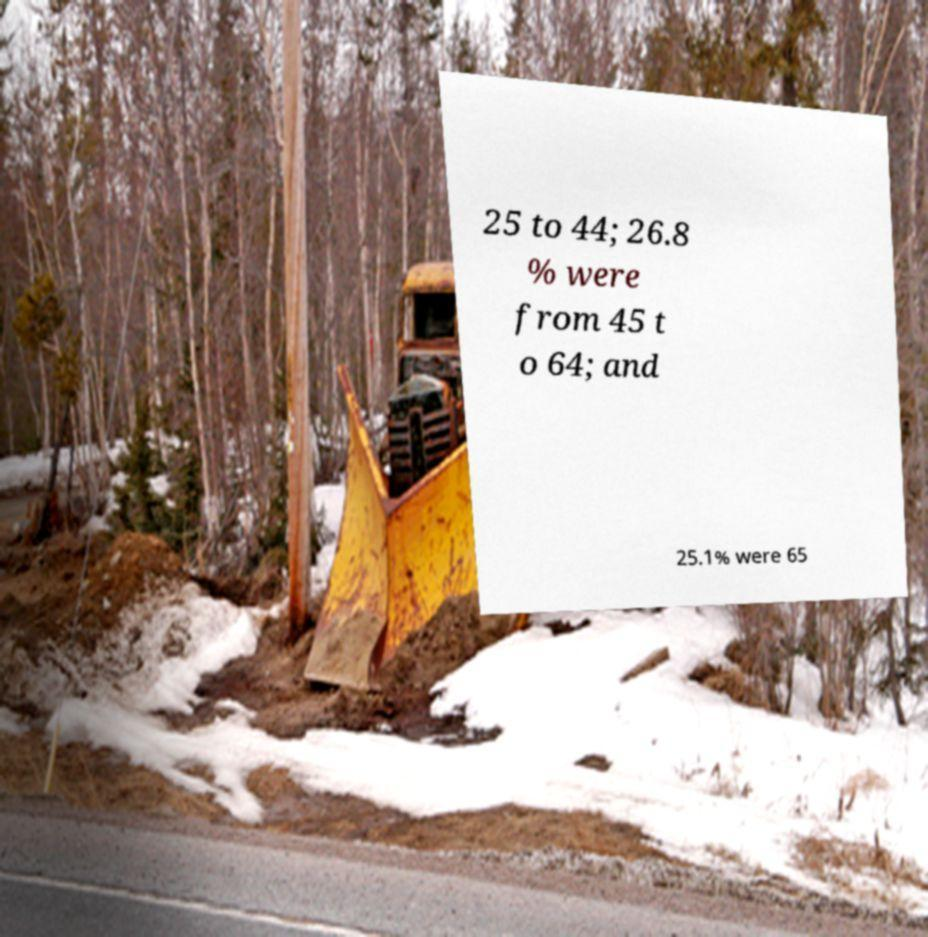For documentation purposes, I need the text within this image transcribed. Could you provide that? 25 to 44; 26.8 % were from 45 t o 64; and 25.1% were 65 